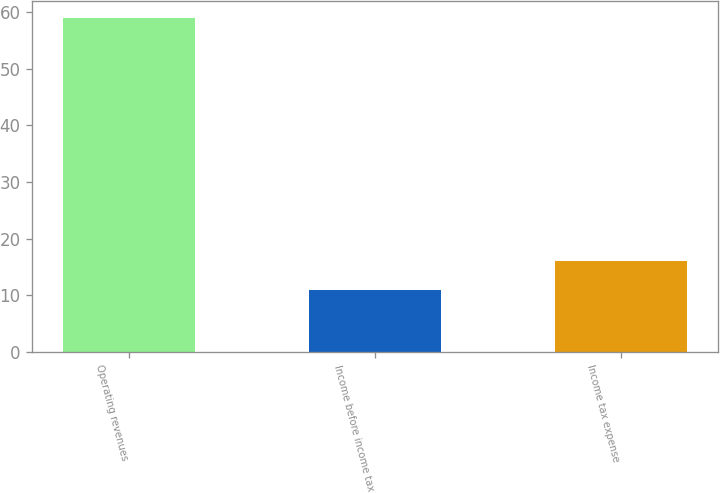Convert chart to OTSL. <chart><loc_0><loc_0><loc_500><loc_500><bar_chart><fcel>Operating revenues<fcel>Income before income tax<fcel>Income tax expense<nl><fcel>59<fcel>11<fcel>16<nl></chart> 